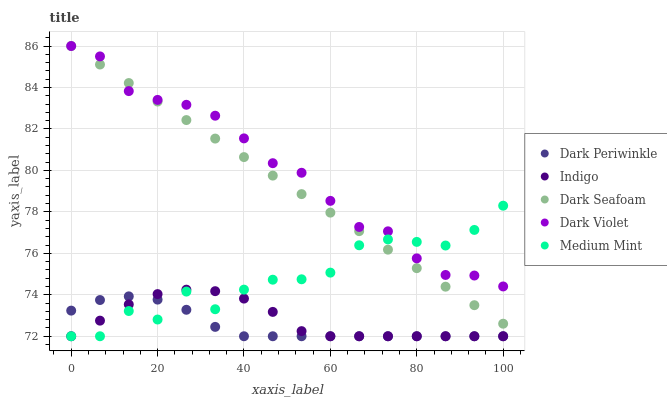Does Dark Periwinkle have the minimum area under the curve?
Answer yes or no. Yes. Does Dark Violet have the maximum area under the curve?
Answer yes or no. Yes. Does Dark Seafoam have the minimum area under the curve?
Answer yes or no. No. Does Dark Seafoam have the maximum area under the curve?
Answer yes or no. No. Is Dark Seafoam the smoothest?
Answer yes or no. Yes. Is Medium Mint the roughest?
Answer yes or no. Yes. Is Indigo the smoothest?
Answer yes or no. No. Is Indigo the roughest?
Answer yes or no. No. Does Medium Mint have the lowest value?
Answer yes or no. Yes. Does Dark Seafoam have the lowest value?
Answer yes or no. No. Does Dark Violet have the highest value?
Answer yes or no. Yes. Does Indigo have the highest value?
Answer yes or no. No. Is Indigo less than Dark Violet?
Answer yes or no. Yes. Is Dark Violet greater than Dark Periwinkle?
Answer yes or no. Yes. Does Medium Mint intersect Dark Periwinkle?
Answer yes or no. Yes. Is Medium Mint less than Dark Periwinkle?
Answer yes or no. No. Is Medium Mint greater than Dark Periwinkle?
Answer yes or no. No. Does Indigo intersect Dark Violet?
Answer yes or no. No. 